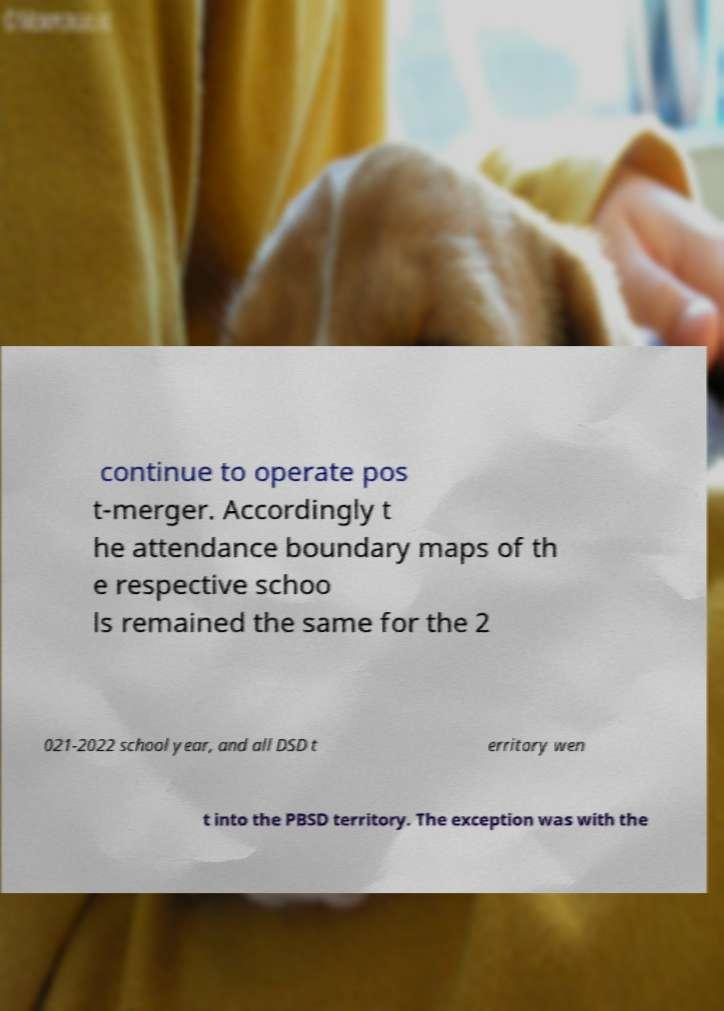I need the written content from this picture converted into text. Can you do that? continue to operate pos t-merger. Accordingly t he attendance boundary maps of th e respective schoo ls remained the same for the 2 021-2022 school year, and all DSD t erritory wen t into the PBSD territory. The exception was with the 